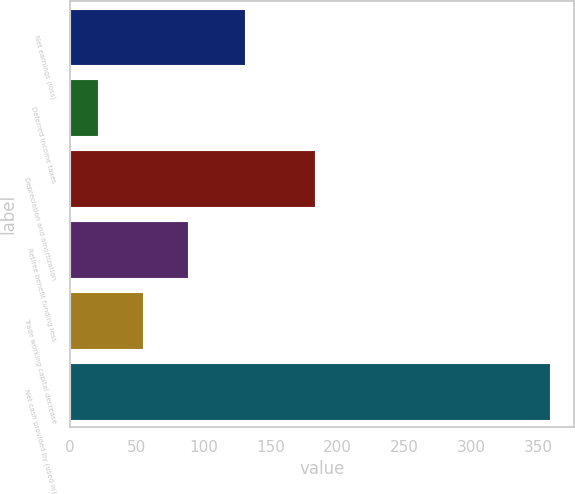<chart> <loc_0><loc_0><loc_500><loc_500><bar_chart><fcel>Net earnings (loss)<fcel>Deferred income taxes<fcel>Depreciation and amortization<fcel>Retiree benefit funding less<fcel>Trade working capital decrease<fcel>Net cash provided by (used in)<nl><fcel>131<fcel>21<fcel>183<fcel>88.6<fcel>54.8<fcel>359<nl></chart> 